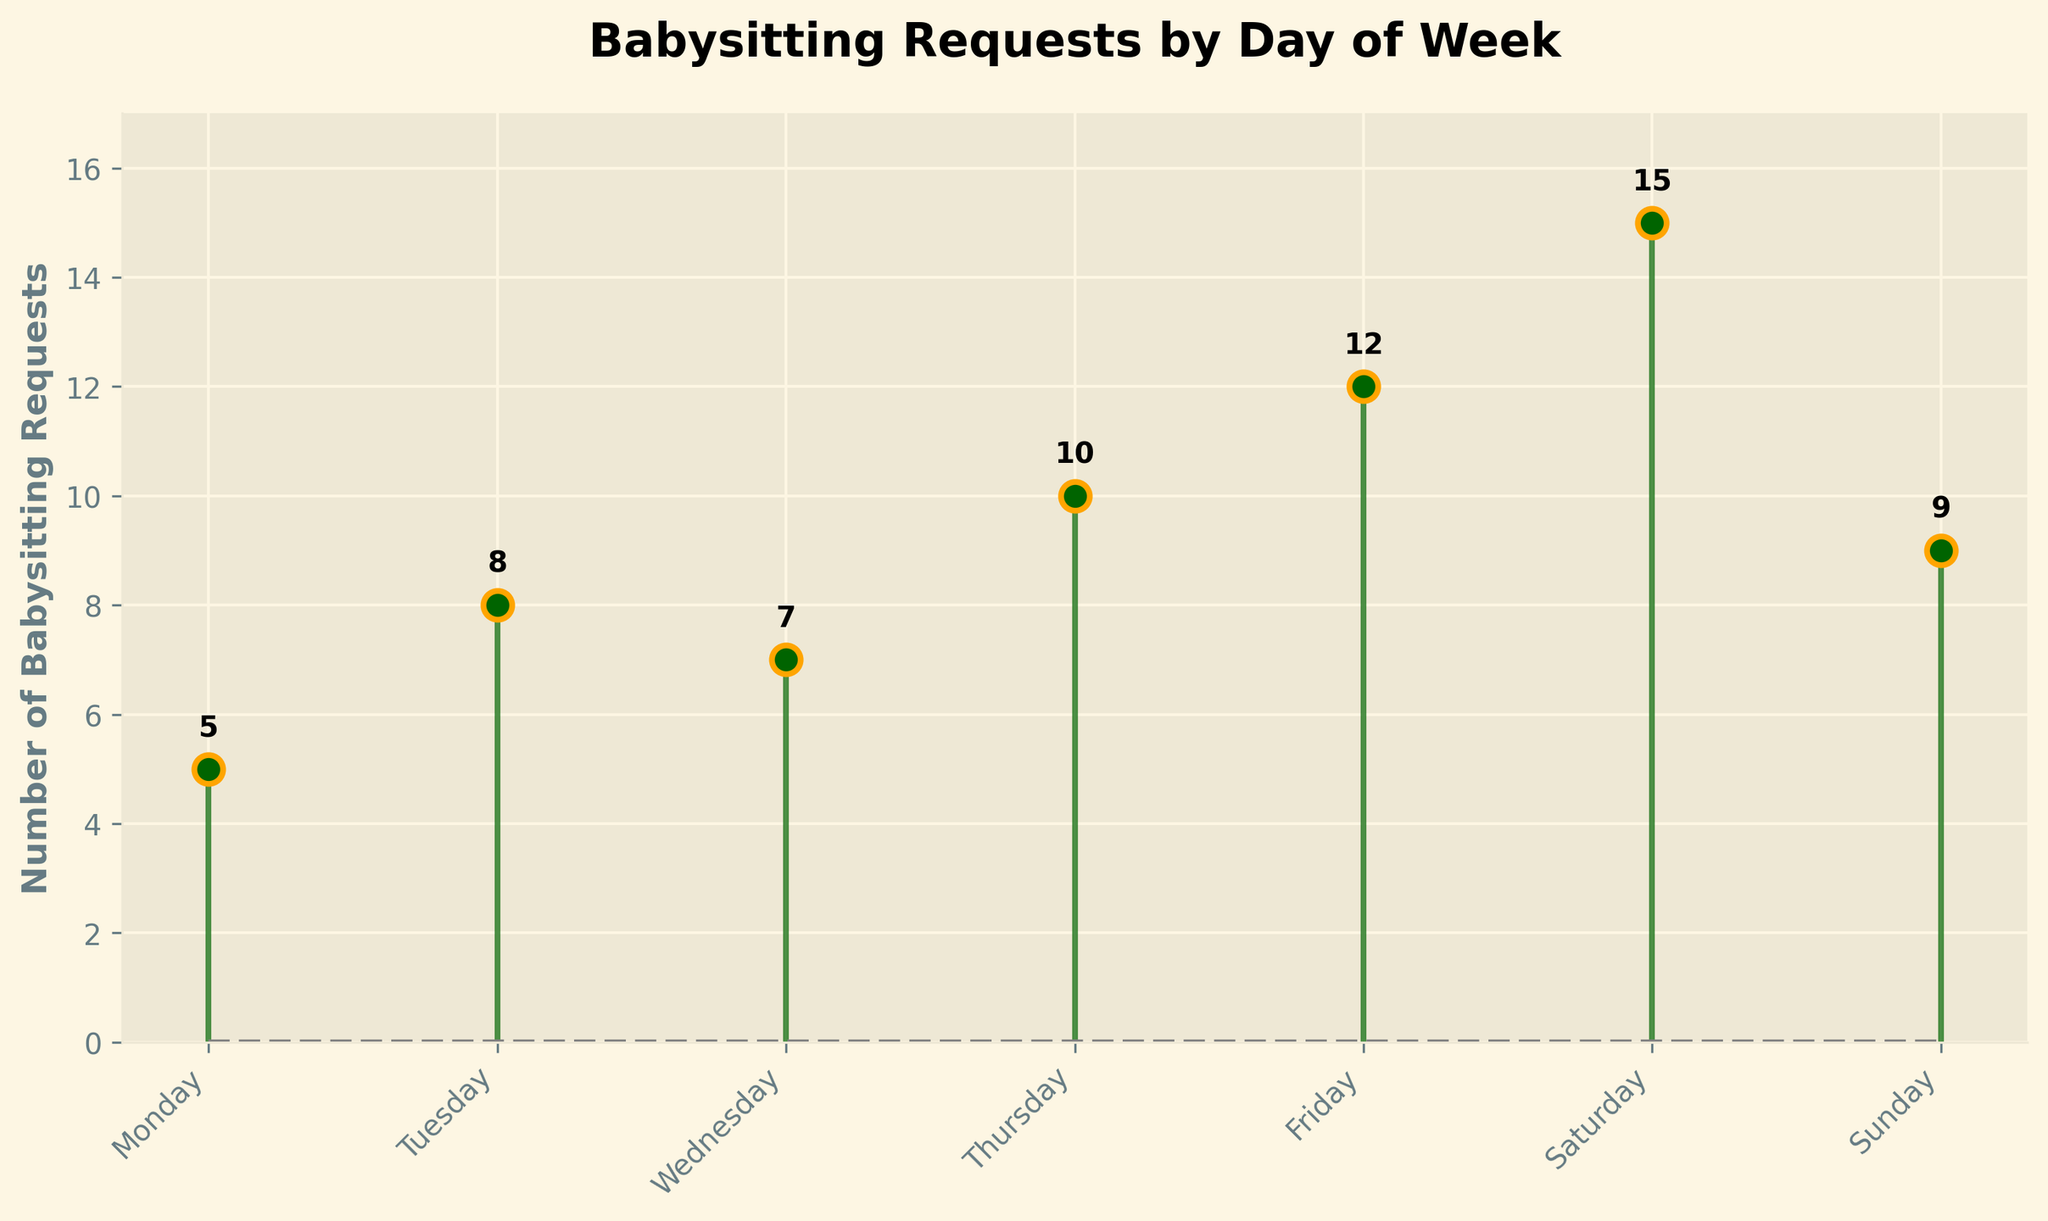What day has the highest number of babysitting requests? The figure shows the number of babysitting requests for each day of the week. Saturday has the highest number of requests, which is 15.
Answer: Saturday What is the total number of babysitting requests for the whole week? Sum the number of babysitting requests for each day of the week: 5 (Mon) + 8 (Tue) + 7 (Wed) + 10 (Thu) + 12 (Fri) + 15 (Sat) + 9 (Sun) = 66.
Answer: 66 Which day has fewer requests: Monday or Tuesday? The figure indicates that Monday has 5 requests, whereas Tuesday has 8 requests. Therefore, Monday has fewer requests than Tuesday.
Answer: Monday How many days had more than 10 babysitting requests? Count the days where the number of requests is greater than 10: Friday (12) and Saturday (15). So, there are 2 days.
Answer: 2 What is the average number of babysitting requests per day? Sum all the requests (5 + 8 + 7 + 10 + 12 + 15 + 9 = 66) and divide by the number of days (7): 66 / 7 = 9.43 (approximately).
Answer: 9.43 Which day shows the largest jump in requests from the previous day? Examining each day-to-day difference: 
- Tuesday to Monday: 8 - 5 = 3
- Wednesday to Tuesday: 7 - 8 = -1
- Thursday to Wednesday: 10 - 7 = 3
- Friday to Thursday: 12 - 10 = 2
- Saturday to Friday: 15 - 12 = 3
- Sunday to Saturday: 9 - 15 = -6
The largest positive difference is a jump of 3 requests, seen on Tuesday, Thursday, and Saturday.
Answer: Tuesday, Thursday, Saturday Does Sunday have more or fewer babysitting requests compared to the average number per day? The average number of requests is 9.43. Sunday has 9 requests, which is slightly fewer than the average of 9.43.
Answer: fewer What is the difference between the highest and lowest number of babysitting requests? The highest number is 15 (on Saturday) and the lowest is 5 (on Monday). The difference is 15 - 5 = 10.
Answer: 10 What is the title of the figure? The title of the figure, as seen at the top of the plot, is "Babysitting Requests by Day of Week".
Answer: Babysitting Requests by Day of Week 